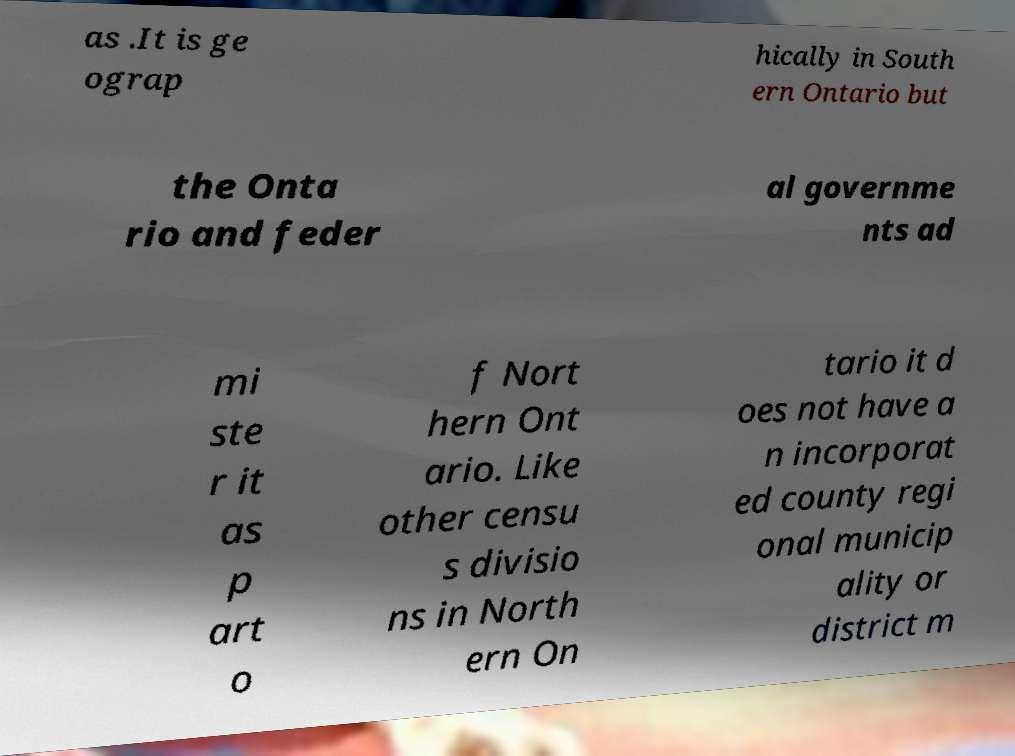Can you read and provide the text displayed in the image?This photo seems to have some interesting text. Can you extract and type it out for me? as .It is ge ograp hically in South ern Ontario but the Onta rio and feder al governme nts ad mi ste r it as p art o f Nort hern Ont ario. Like other censu s divisio ns in North ern On tario it d oes not have a n incorporat ed county regi onal municip ality or district m 